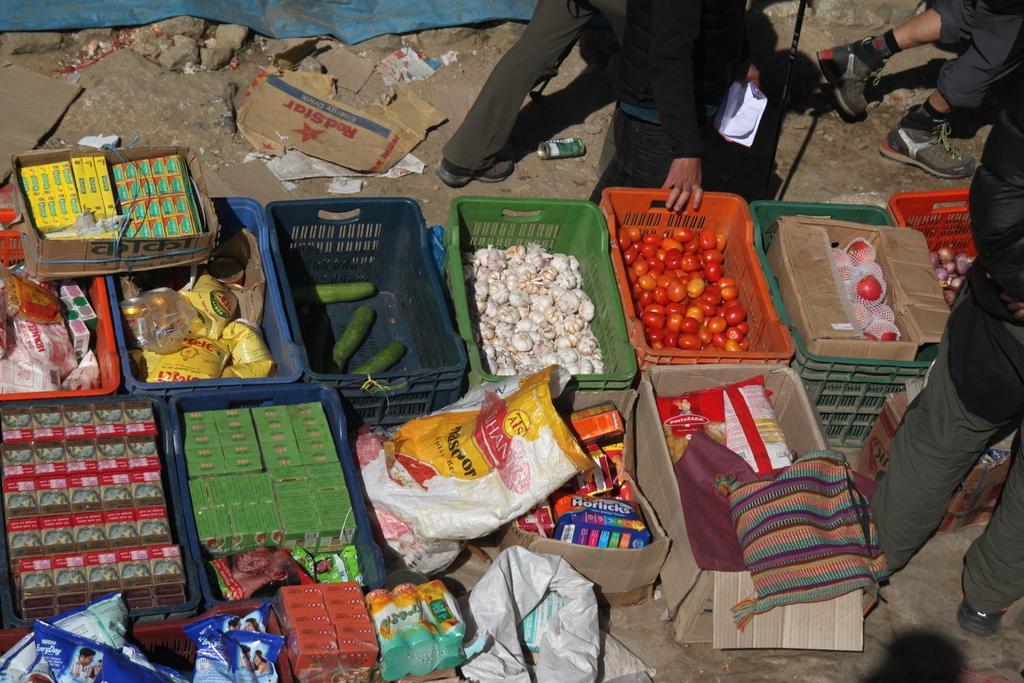How would you summarize this image in a sentence or two? These are the baskets, which contain the food packets, cucumbers, garlic, tomatoes and few other items in it. I can see two people standing. This looks like a cardboard box and papers lying on the ground. On the right side of the image, I can see a person walking. 